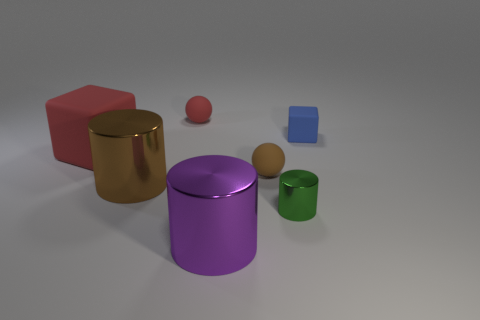Is there another cube made of the same material as the large red block?
Your response must be concise. Yes. Is there a tiny blue thing that is in front of the large shiny cylinder behind the big shiny object that is on the right side of the brown cylinder?
Provide a short and direct response. No. There is a red block; are there any red rubber objects left of it?
Your answer should be very brief. No. Are there any metallic cylinders that have the same color as the small rubber cube?
Give a very brief answer. No. How many tiny things are either red things or rubber blocks?
Ensure brevity in your answer.  2. Are the tiny object behind the small blue matte thing and the big red block made of the same material?
Offer a terse response. Yes. What shape is the brown object right of the big metal cylinder on the left side of the rubber sphere that is to the left of the brown rubber sphere?
Keep it short and to the point. Sphere. What number of purple objects are either metallic cylinders or big metallic objects?
Provide a short and direct response. 1. Is the number of large things that are to the left of the big purple object the same as the number of green metallic cylinders that are left of the large red object?
Provide a succinct answer. No. There is a red rubber object that is behind the red cube; is its shape the same as the small rubber object in front of the small cube?
Provide a succinct answer. Yes. 